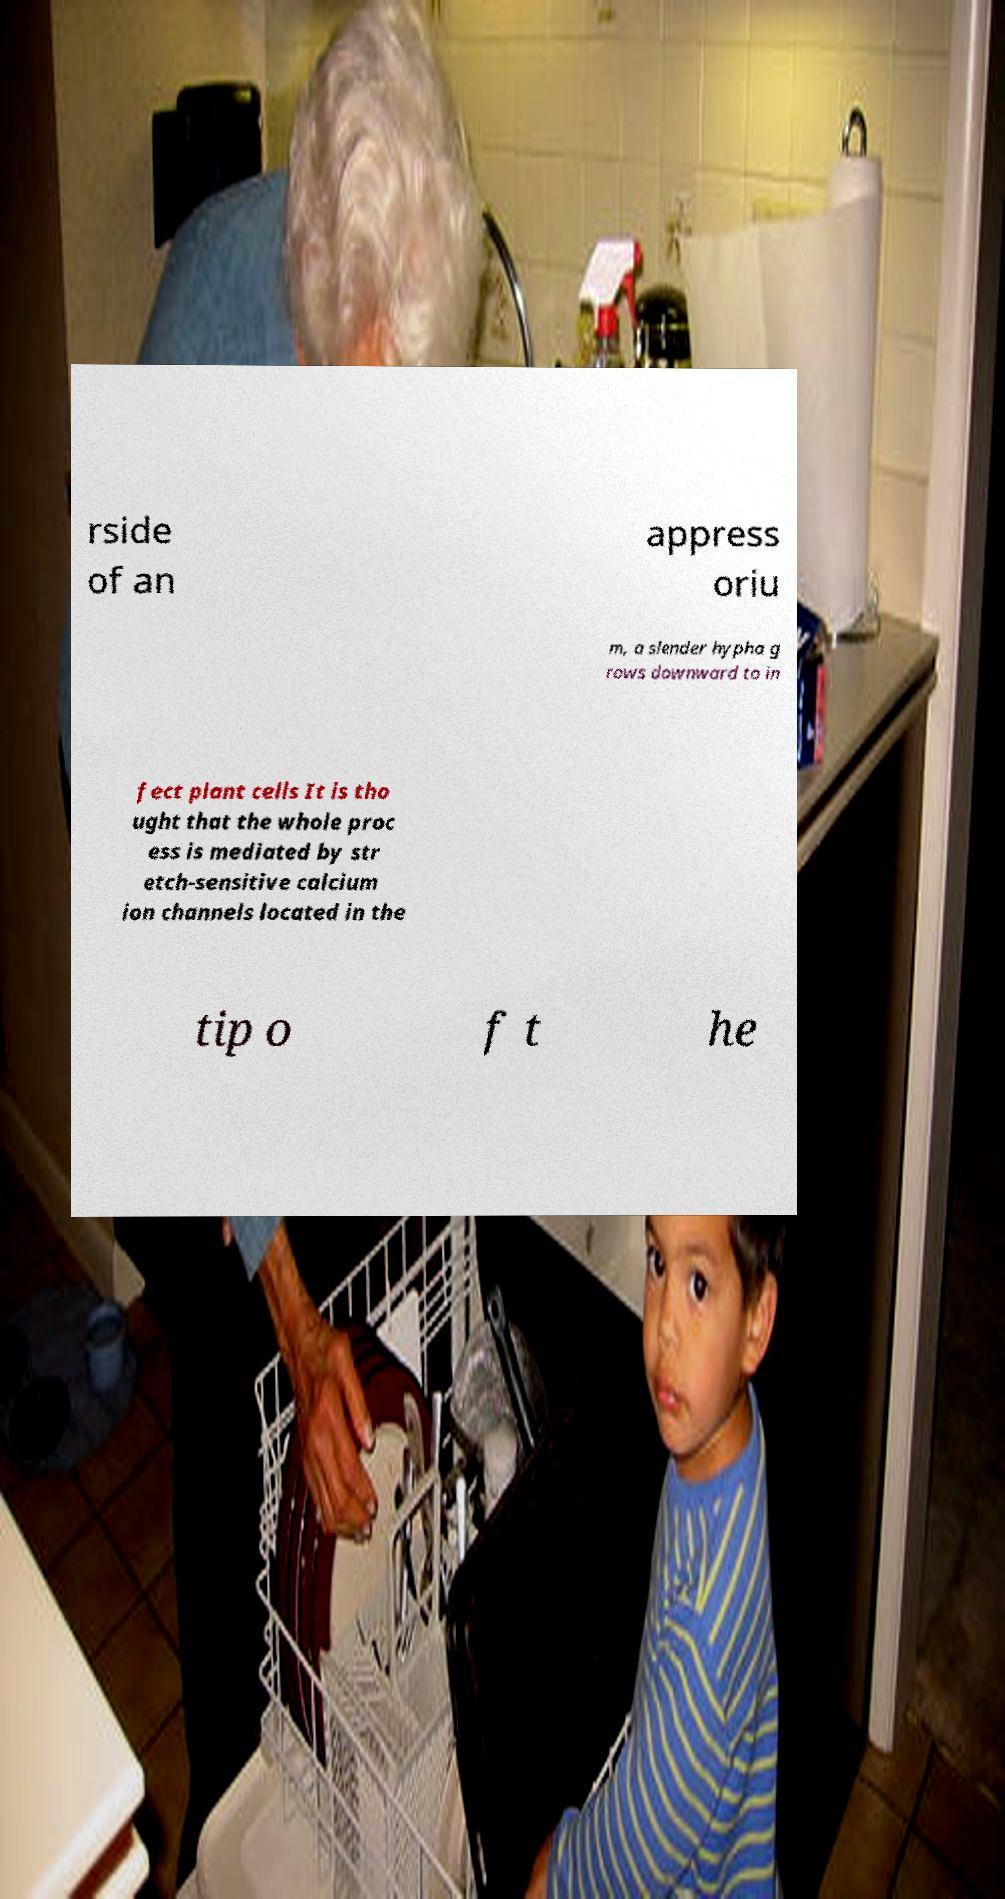Could you extract and type out the text from this image? rside of an appress oriu m, a slender hypha g rows downward to in fect plant cells It is tho ught that the whole proc ess is mediated by str etch-sensitive calcium ion channels located in the tip o f t he 